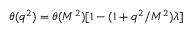<formula> <loc_0><loc_0><loc_500><loc_500>\theta ( q ^ { 2 } ) = \theta ( M ^ { 2 } ) [ 1 - ( 1 + q ^ { 2 } / M ^ { 2 } ) \lambda ]</formula> 